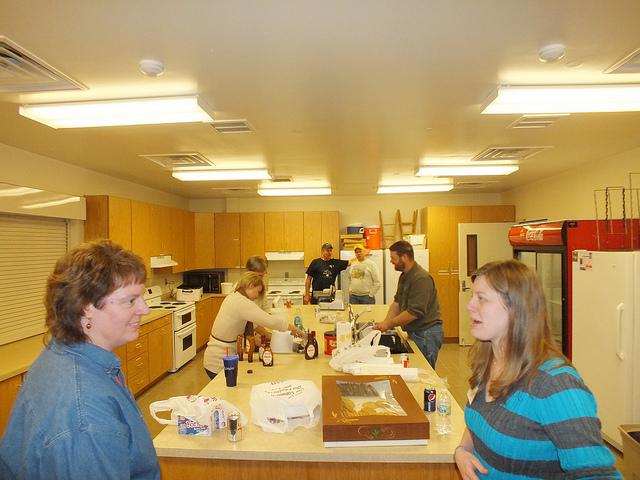What was in the brown box in the foreground?
Answer briefly. Donuts. Does the women in the striped shirt look happy?
Quick response, please. No. How many people are standing?
Be succinct. 7. What brand of soda is advertised on the cooler?
Answer briefly. Coca cola. Is there a projector on the ceiling?
Short answer required. No. How many people are eating?
Answer briefly. 0. 